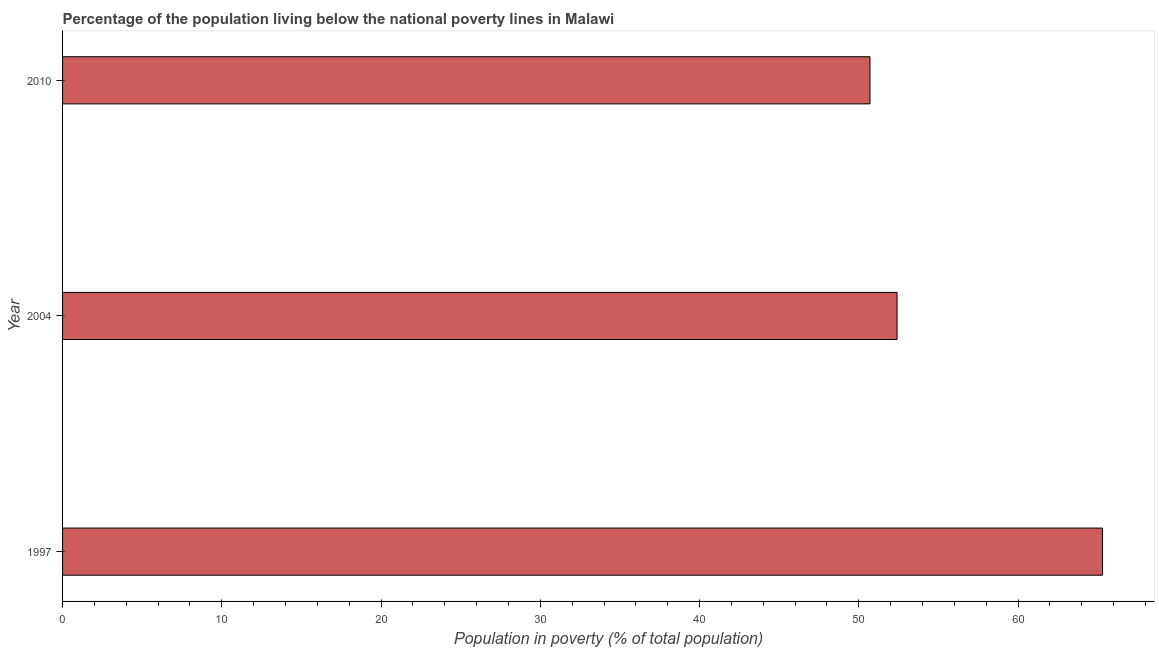Does the graph contain any zero values?
Provide a short and direct response. No. Does the graph contain grids?
Provide a succinct answer. No. What is the title of the graph?
Offer a very short reply. Percentage of the population living below the national poverty lines in Malawi. What is the label or title of the X-axis?
Keep it short and to the point. Population in poverty (% of total population). What is the label or title of the Y-axis?
Keep it short and to the point. Year. What is the percentage of population living below poverty line in 1997?
Offer a terse response. 65.3. Across all years, what is the maximum percentage of population living below poverty line?
Make the answer very short. 65.3. Across all years, what is the minimum percentage of population living below poverty line?
Offer a very short reply. 50.7. In which year was the percentage of population living below poverty line minimum?
Your response must be concise. 2010. What is the sum of the percentage of population living below poverty line?
Your answer should be very brief. 168.4. What is the average percentage of population living below poverty line per year?
Offer a very short reply. 56.13. What is the median percentage of population living below poverty line?
Ensure brevity in your answer.  52.4. In how many years, is the percentage of population living below poverty line greater than 30 %?
Make the answer very short. 3. Do a majority of the years between 2010 and 1997 (inclusive) have percentage of population living below poverty line greater than 10 %?
Your answer should be very brief. Yes. What is the ratio of the percentage of population living below poverty line in 2004 to that in 2010?
Offer a terse response. 1.03. What is the difference between the highest and the second highest percentage of population living below poverty line?
Ensure brevity in your answer.  12.9. Is the sum of the percentage of population living below poverty line in 2004 and 2010 greater than the maximum percentage of population living below poverty line across all years?
Offer a terse response. Yes. What is the difference between the highest and the lowest percentage of population living below poverty line?
Your answer should be compact. 14.6. In how many years, is the percentage of population living below poverty line greater than the average percentage of population living below poverty line taken over all years?
Provide a short and direct response. 1. How many bars are there?
Ensure brevity in your answer.  3. Are all the bars in the graph horizontal?
Provide a succinct answer. Yes. Are the values on the major ticks of X-axis written in scientific E-notation?
Your answer should be very brief. No. What is the Population in poverty (% of total population) of 1997?
Give a very brief answer. 65.3. What is the Population in poverty (% of total population) of 2004?
Provide a short and direct response. 52.4. What is the Population in poverty (% of total population) in 2010?
Your response must be concise. 50.7. What is the difference between the Population in poverty (% of total population) in 1997 and 2004?
Your answer should be compact. 12.9. What is the ratio of the Population in poverty (% of total population) in 1997 to that in 2004?
Give a very brief answer. 1.25. What is the ratio of the Population in poverty (% of total population) in 1997 to that in 2010?
Offer a very short reply. 1.29. What is the ratio of the Population in poverty (% of total population) in 2004 to that in 2010?
Your answer should be compact. 1.03. 